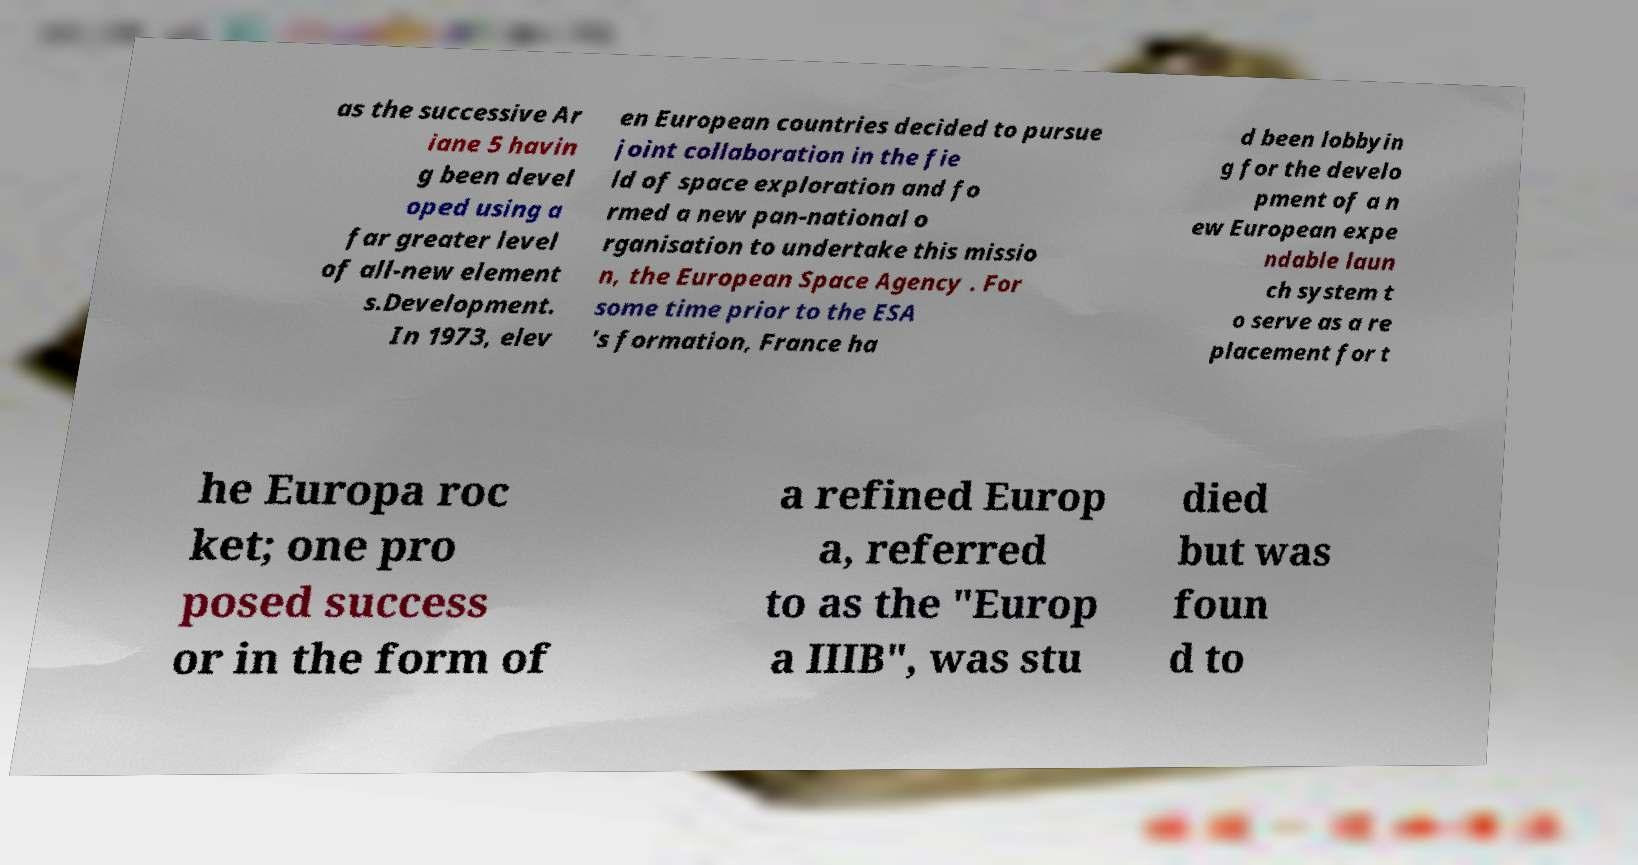For documentation purposes, I need the text within this image transcribed. Could you provide that? as the successive Ar iane 5 havin g been devel oped using a far greater level of all-new element s.Development. In 1973, elev en European countries decided to pursue joint collaboration in the fie ld of space exploration and fo rmed a new pan-national o rganisation to undertake this missio n, the European Space Agency . For some time prior to the ESA 's formation, France ha d been lobbyin g for the develo pment of a n ew European expe ndable laun ch system t o serve as a re placement for t he Europa roc ket; one pro posed success or in the form of a refined Europ a, referred to as the "Europ a IIIB", was stu died but was foun d to 